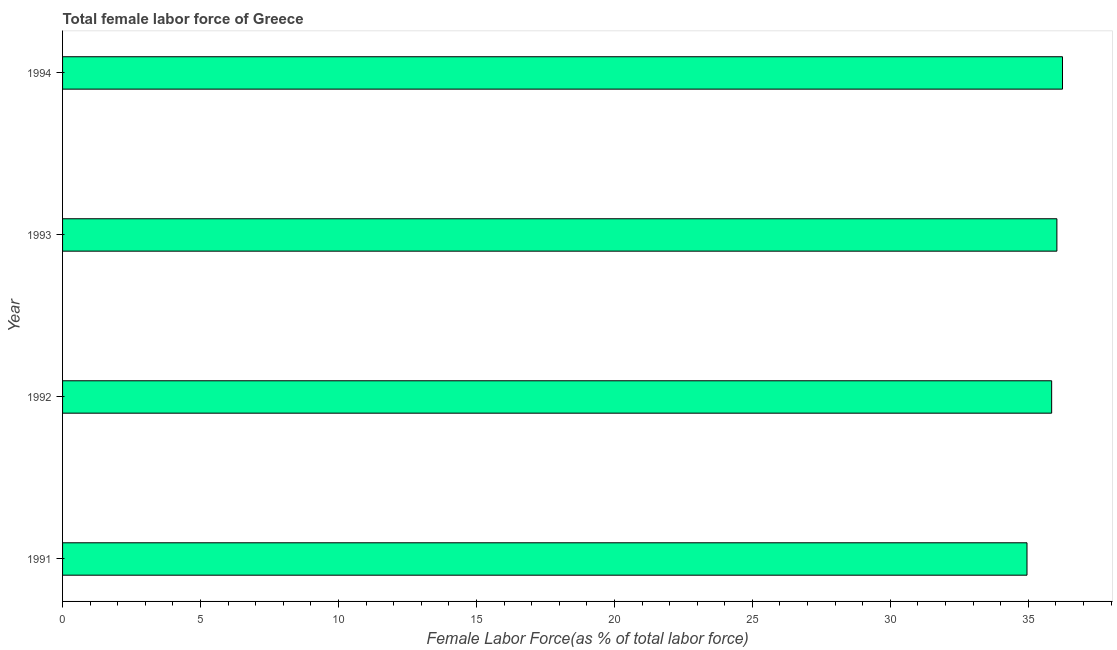Does the graph contain grids?
Keep it short and to the point. No. What is the title of the graph?
Give a very brief answer. Total female labor force of Greece. What is the label or title of the X-axis?
Provide a short and direct response. Female Labor Force(as % of total labor force). What is the label or title of the Y-axis?
Your response must be concise. Year. What is the total female labor force in 1991?
Your answer should be compact. 34.95. Across all years, what is the maximum total female labor force?
Keep it short and to the point. 36.24. Across all years, what is the minimum total female labor force?
Give a very brief answer. 34.95. In which year was the total female labor force minimum?
Offer a terse response. 1991. What is the sum of the total female labor force?
Ensure brevity in your answer.  143.07. What is the difference between the total female labor force in 1991 and 1994?
Keep it short and to the point. -1.29. What is the average total female labor force per year?
Ensure brevity in your answer.  35.77. What is the median total female labor force?
Your response must be concise. 35.94. Do a majority of the years between 1993 and 1992 (inclusive) have total female labor force greater than 30 %?
Make the answer very short. No. Is the total female labor force in 1991 less than that in 1992?
Your answer should be very brief. Yes. Is the difference between the total female labor force in 1992 and 1993 greater than the difference between any two years?
Your answer should be very brief. No. What is the difference between the highest and the second highest total female labor force?
Offer a very short reply. 0.2. What is the difference between the highest and the lowest total female labor force?
Make the answer very short. 1.29. How many bars are there?
Provide a short and direct response. 4. Are all the bars in the graph horizontal?
Offer a terse response. Yes. Are the values on the major ticks of X-axis written in scientific E-notation?
Offer a very short reply. No. What is the Female Labor Force(as % of total labor force) of 1991?
Give a very brief answer. 34.95. What is the Female Labor Force(as % of total labor force) of 1992?
Make the answer very short. 35.85. What is the Female Labor Force(as % of total labor force) in 1993?
Offer a terse response. 36.04. What is the Female Labor Force(as % of total labor force) in 1994?
Ensure brevity in your answer.  36.24. What is the difference between the Female Labor Force(as % of total labor force) in 1991 and 1992?
Your answer should be compact. -0.89. What is the difference between the Female Labor Force(as % of total labor force) in 1991 and 1993?
Your response must be concise. -1.08. What is the difference between the Female Labor Force(as % of total labor force) in 1991 and 1994?
Provide a succinct answer. -1.29. What is the difference between the Female Labor Force(as % of total labor force) in 1992 and 1993?
Offer a very short reply. -0.19. What is the difference between the Female Labor Force(as % of total labor force) in 1992 and 1994?
Provide a succinct answer. -0.39. What is the difference between the Female Labor Force(as % of total labor force) in 1993 and 1994?
Provide a succinct answer. -0.2. What is the ratio of the Female Labor Force(as % of total labor force) in 1991 to that in 1992?
Give a very brief answer. 0.97. What is the ratio of the Female Labor Force(as % of total labor force) in 1991 to that in 1994?
Offer a terse response. 0.96. What is the ratio of the Female Labor Force(as % of total labor force) in 1992 to that in 1993?
Your response must be concise. 0.99. What is the ratio of the Female Labor Force(as % of total labor force) in 1992 to that in 1994?
Your answer should be very brief. 0.99. 